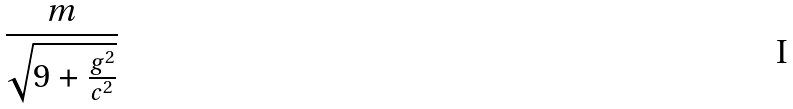<formula> <loc_0><loc_0><loc_500><loc_500>\frac { m } { \sqrt { 9 + \frac { g ^ { 2 } } { c ^ { 2 } } } }</formula> 